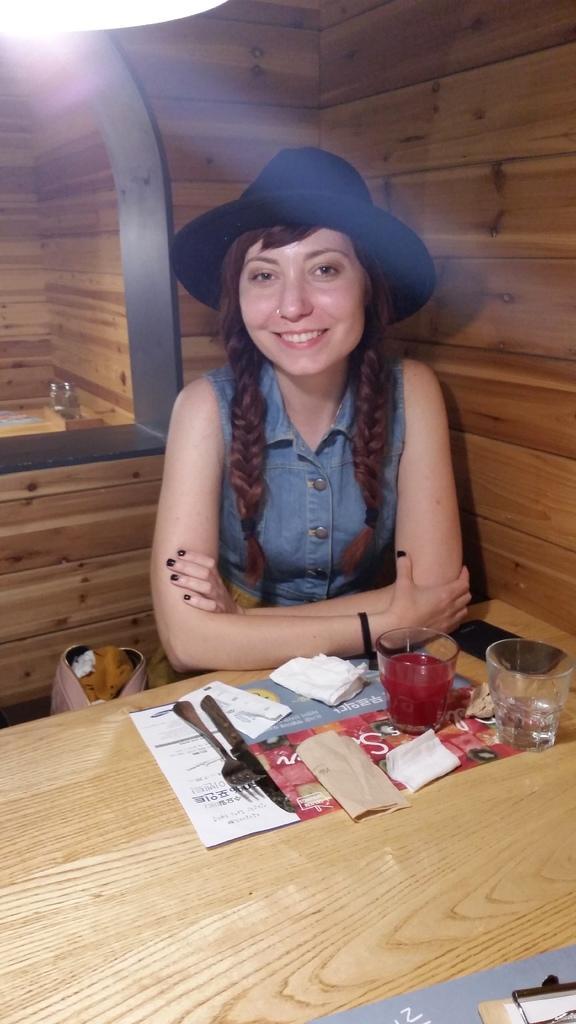Please provide a concise description of this image. In this picture there is a woman sitting a besides a table and a wall. She is wearing a denim jacket and the black hat. On the table there are glasses, fork, spoon and some tissues. To the right bottom there is a pad. In the background there is a wall. 